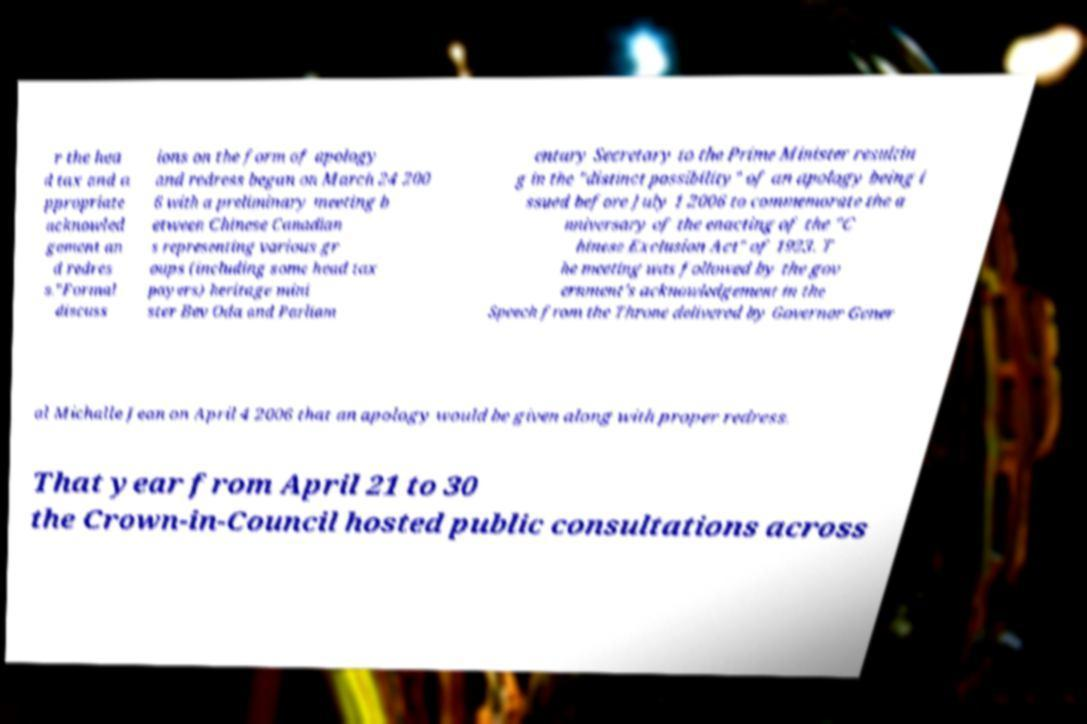For documentation purposes, I need the text within this image transcribed. Could you provide that? r the hea d tax and a ppropriate acknowled gement an d redres s."Formal discuss ions on the form of apology and redress began on March 24 200 6 with a preliminary meeting b etween Chinese Canadian s representing various gr oups (including some head tax payers) heritage mini ster Bev Oda and Parliam entary Secretary to the Prime Minister resultin g in the "distinct possibility" of an apology being i ssued before July 1 2006 to commemorate the a nniversary of the enacting of the "C hinese Exclusion Act" of 1923. T he meeting was followed by the gov ernment's acknowledgement in the Speech from the Throne delivered by Governor Gener al Michalle Jean on April 4 2006 that an apology would be given along with proper redress. That year from April 21 to 30 the Crown-in-Council hosted public consultations across 